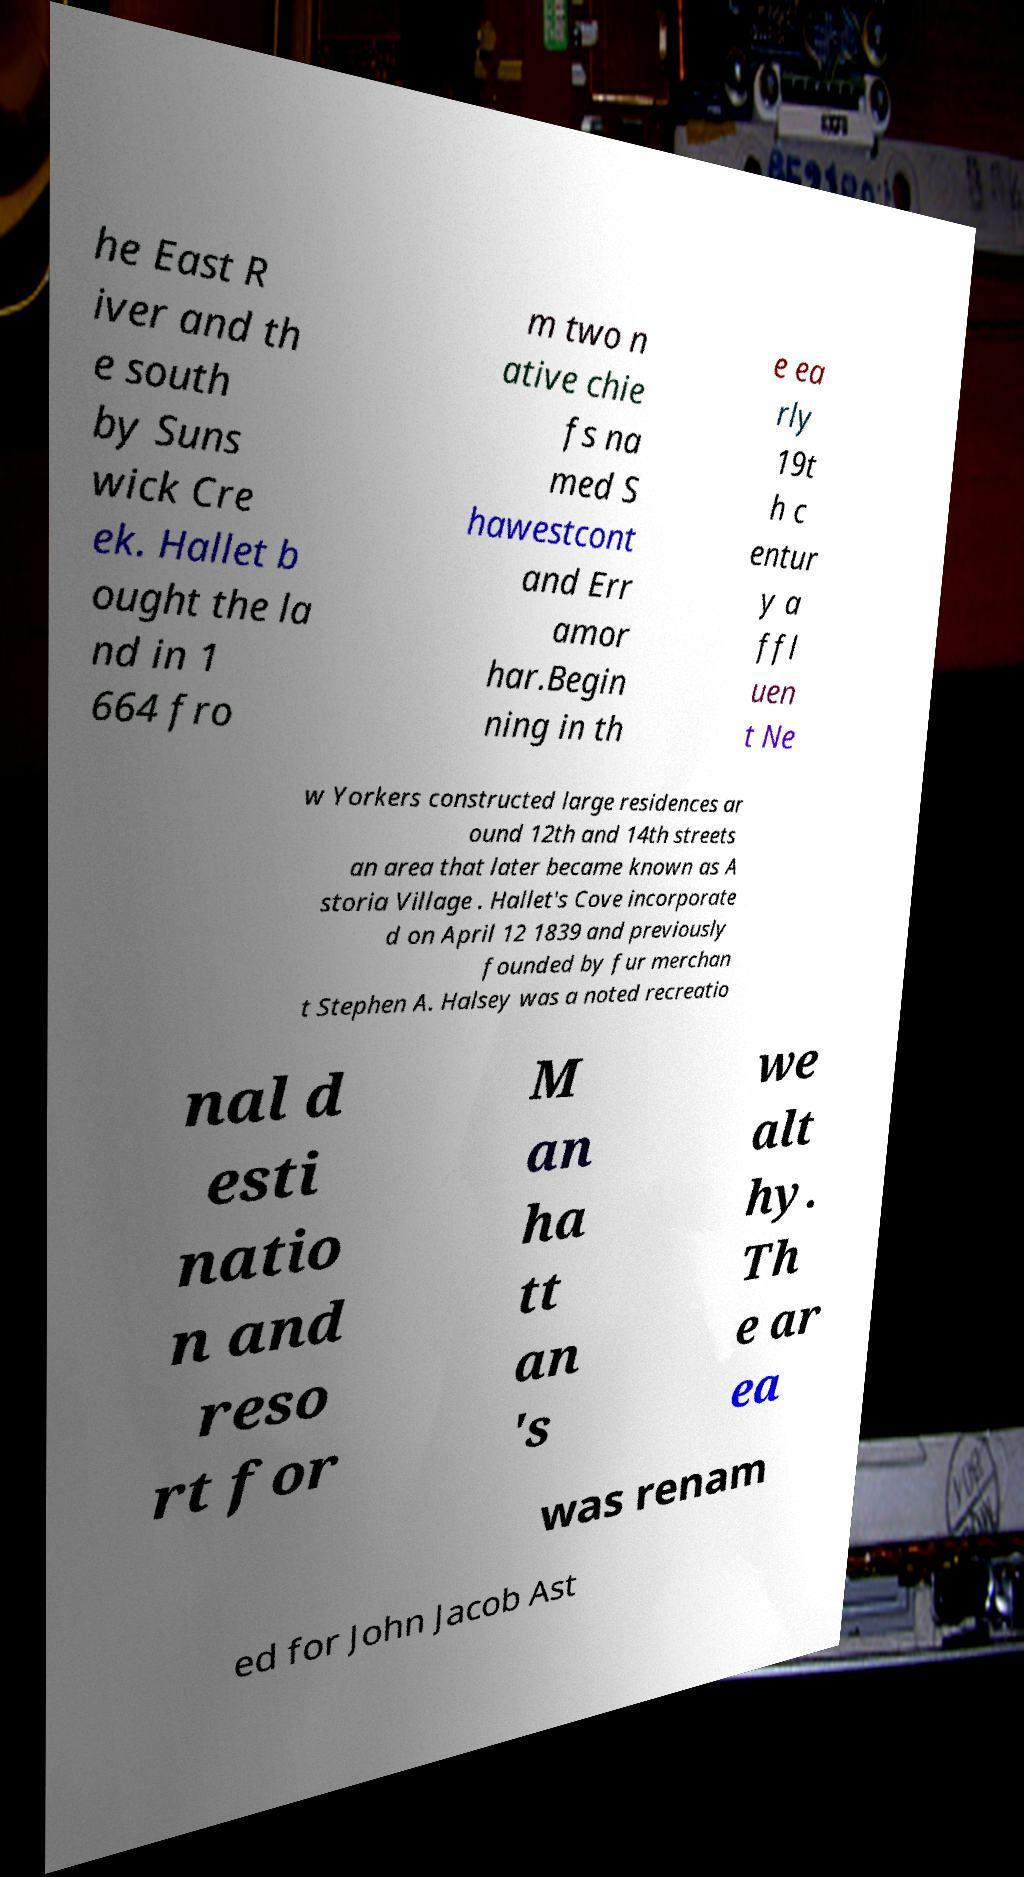Can you accurately transcribe the text from the provided image for me? he East R iver and th e south by Suns wick Cre ek. Hallet b ought the la nd in 1 664 fro m two n ative chie fs na med S hawestcont and Err amor har.Begin ning in th e ea rly 19t h c entur y a ffl uen t Ne w Yorkers constructed large residences ar ound 12th and 14th streets an area that later became known as A storia Village . Hallet's Cove incorporate d on April 12 1839 and previously founded by fur merchan t Stephen A. Halsey was a noted recreatio nal d esti natio n and reso rt for M an ha tt an 's we alt hy. Th e ar ea was renam ed for John Jacob Ast 